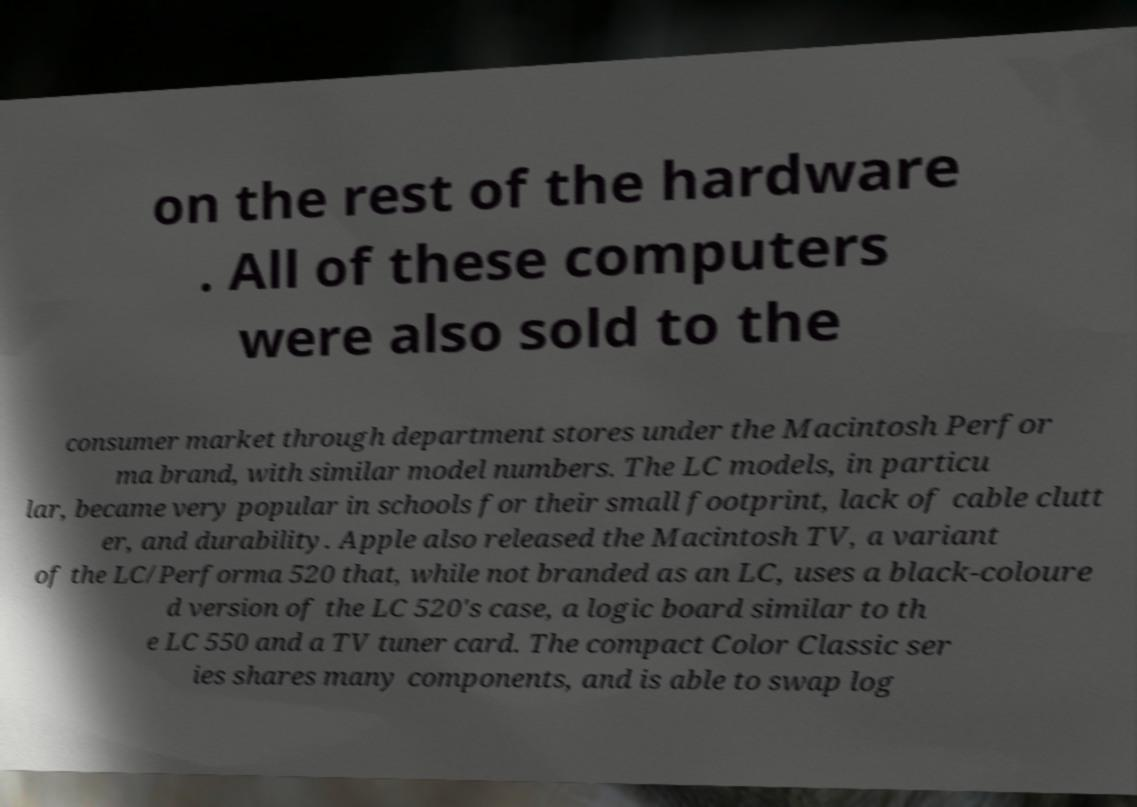What messages or text are displayed in this image? I need them in a readable, typed format. on the rest of the hardware . All of these computers were also sold to the consumer market through department stores under the Macintosh Perfor ma brand, with similar model numbers. The LC models, in particu lar, became very popular in schools for their small footprint, lack of cable clutt er, and durability. Apple also released the Macintosh TV, a variant of the LC/Performa 520 that, while not branded as an LC, uses a black-coloure d version of the LC 520's case, a logic board similar to th e LC 550 and a TV tuner card. The compact Color Classic ser ies shares many components, and is able to swap log 